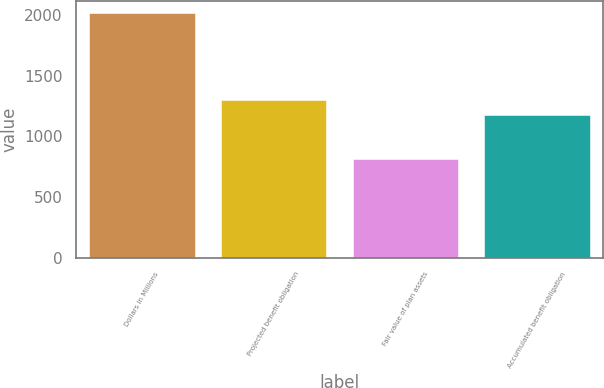Convert chart to OTSL. <chart><loc_0><loc_0><loc_500><loc_500><bar_chart><fcel>Dollars in Millions<fcel>Projected benefit obligation<fcel>Fair value of plan assets<fcel>Accumulated benefit obligation<nl><fcel>2018<fcel>1301.1<fcel>817<fcel>1181<nl></chart> 